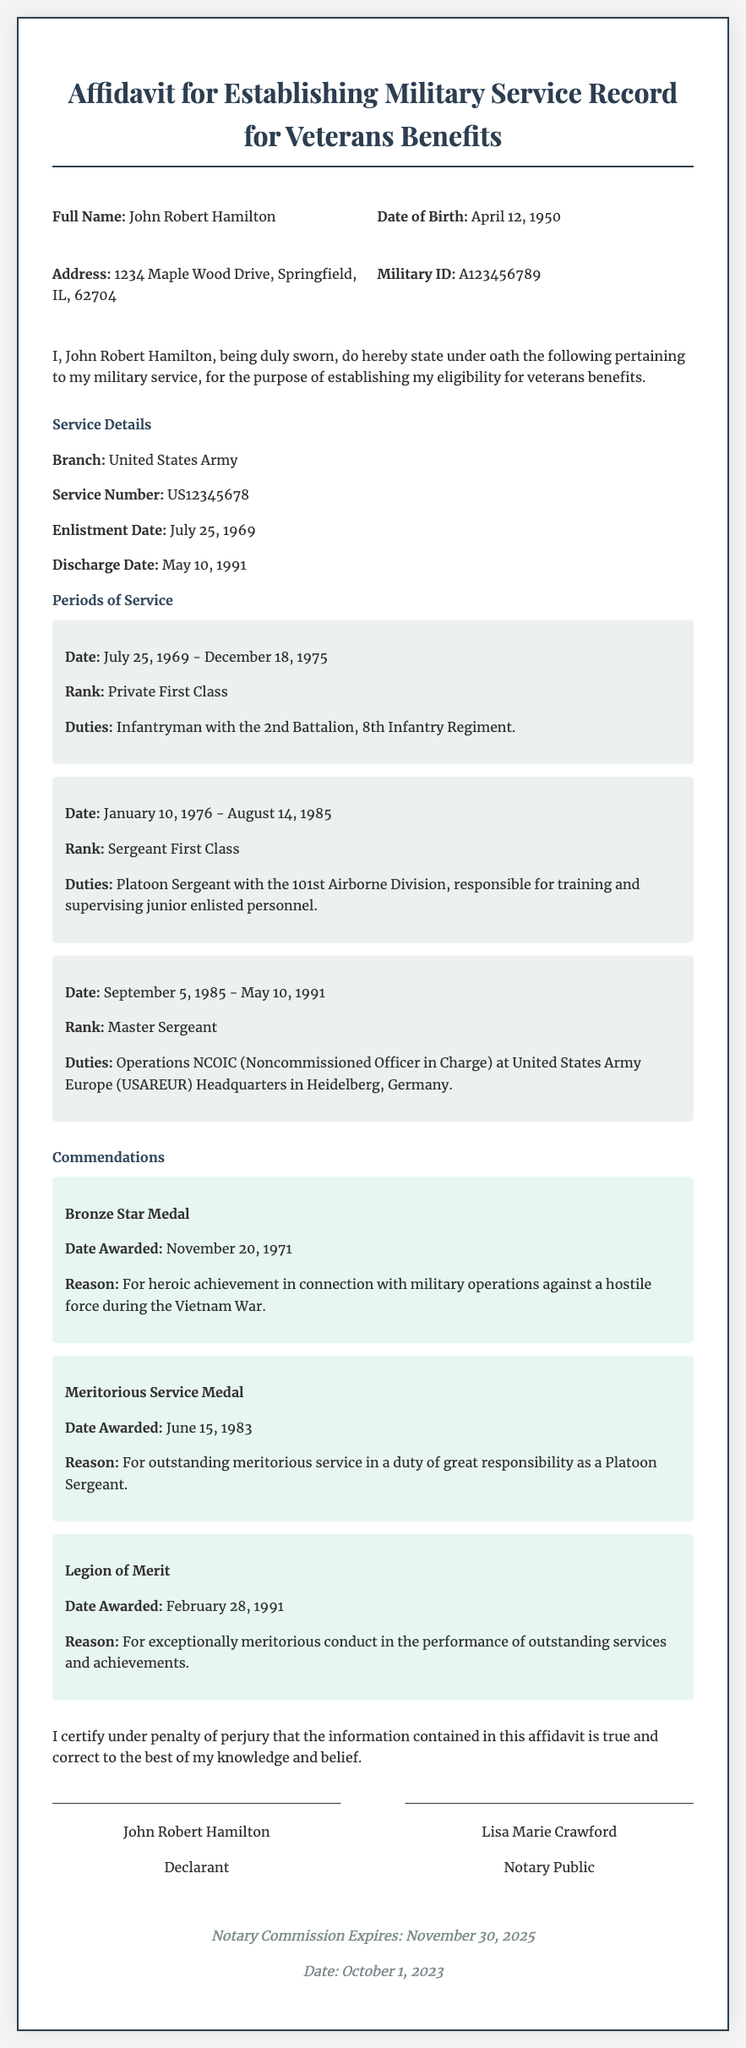What is the full name of the declarant? The declarant's full name is stated at the beginning of the document.
Answer: John Robert Hamilton What is the enlistment date? The enlistment date is specified in the service details section of the document.
Answer: July 25, 1969 What is the latest rank held by the declarant? The latest rank is mentioned in the periods of service section.
Answer: Master Sergeant How many periods of service are detailed in the document? The number of periods can be counted from the sections detailing service dates and ranks.
Answer: Three Which medal was awarded on November 20, 1971? The specific medal awarded on that date is mentioned in the commendations section.
Answer: Bronze Star Medal What is the reason for the Legions of Merit award? The reason is provided in the commendation section under the corresponding medal.
Answer: For exceptionally meritorious conduct in the performance of outstanding services and achievements What is the address of the declarant? The declarant's address is found in the declarant information section.
Answer: 1234 Maple Wood Drive, Springfield, IL, 62704 Who is the notary public for this affidavit? The notary public's name is provided in the signature area of the document.
Answer: Lisa Marie Crawford 